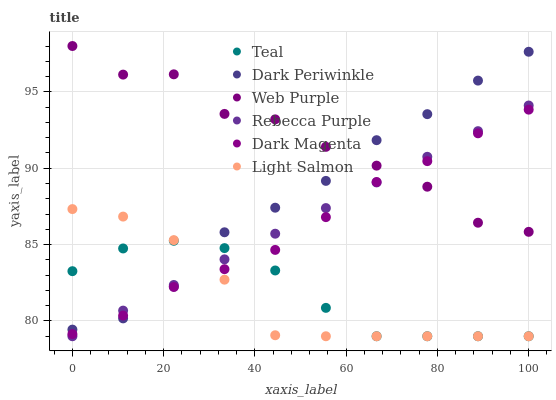Does Light Salmon have the minimum area under the curve?
Answer yes or no. Yes. Does Web Purple have the maximum area under the curve?
Answer yes or no. Yes. Does Dark Magenta have the minimum area under the curve?
Answer yes or no. No. Does Dark Magenta have the maximum area under the curve?
Answer yes or no. No. Is Rebecca Purple the smoothest?
Answer yes or no. Yes. Is Web Purple the roughest?
Answer yes or no. Yes. Is Dark Magenta the smoothest?
Answer yes or no. No. Is Dark Magenta the roughest?
Answer yes or no. No. Does Light Salmon have the lowest value?
Answer yes or no. Yes. Does Dark Magenta have the lowest value?
Answer yes or no. No. Does Web Purple have the highest value?
Answer yes or no. Yes. Does Dark Magenta have the highest value?
Answer yes or no. No. Is Teal less than Web Purple?
Answer yes or no. Yes. Is Web Purple greater than Teal?
Answer yes or no. Yes. Does Light Salmon intersect Rebecca Purple?
Answer yes or no. Yes. Is Light Salmon less than Rebecca Purple?
Answer yes or no. No. Is Light Salmon greater than Rebecca Purple?
Answer yes or no. No. Does Teal intersect Web Purple?
Answer yes or no. No. 